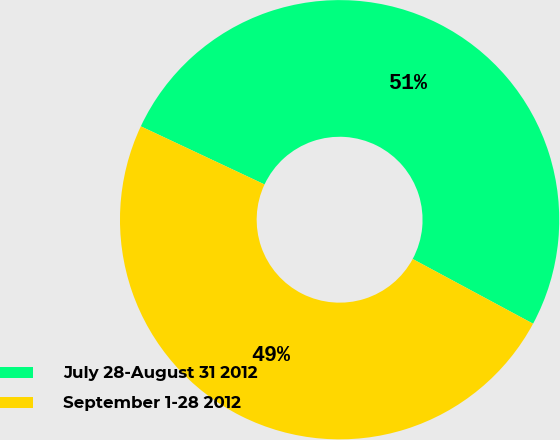Convert chart to OTSL. <chart><loc_0><loc_0><loc_500><loc_500><pie_chart><fcel>July 28-August 31 2012<fcel>September 1-28 2012<nl><fcel>50.86%<fcel>49.14%<nl></chart> 